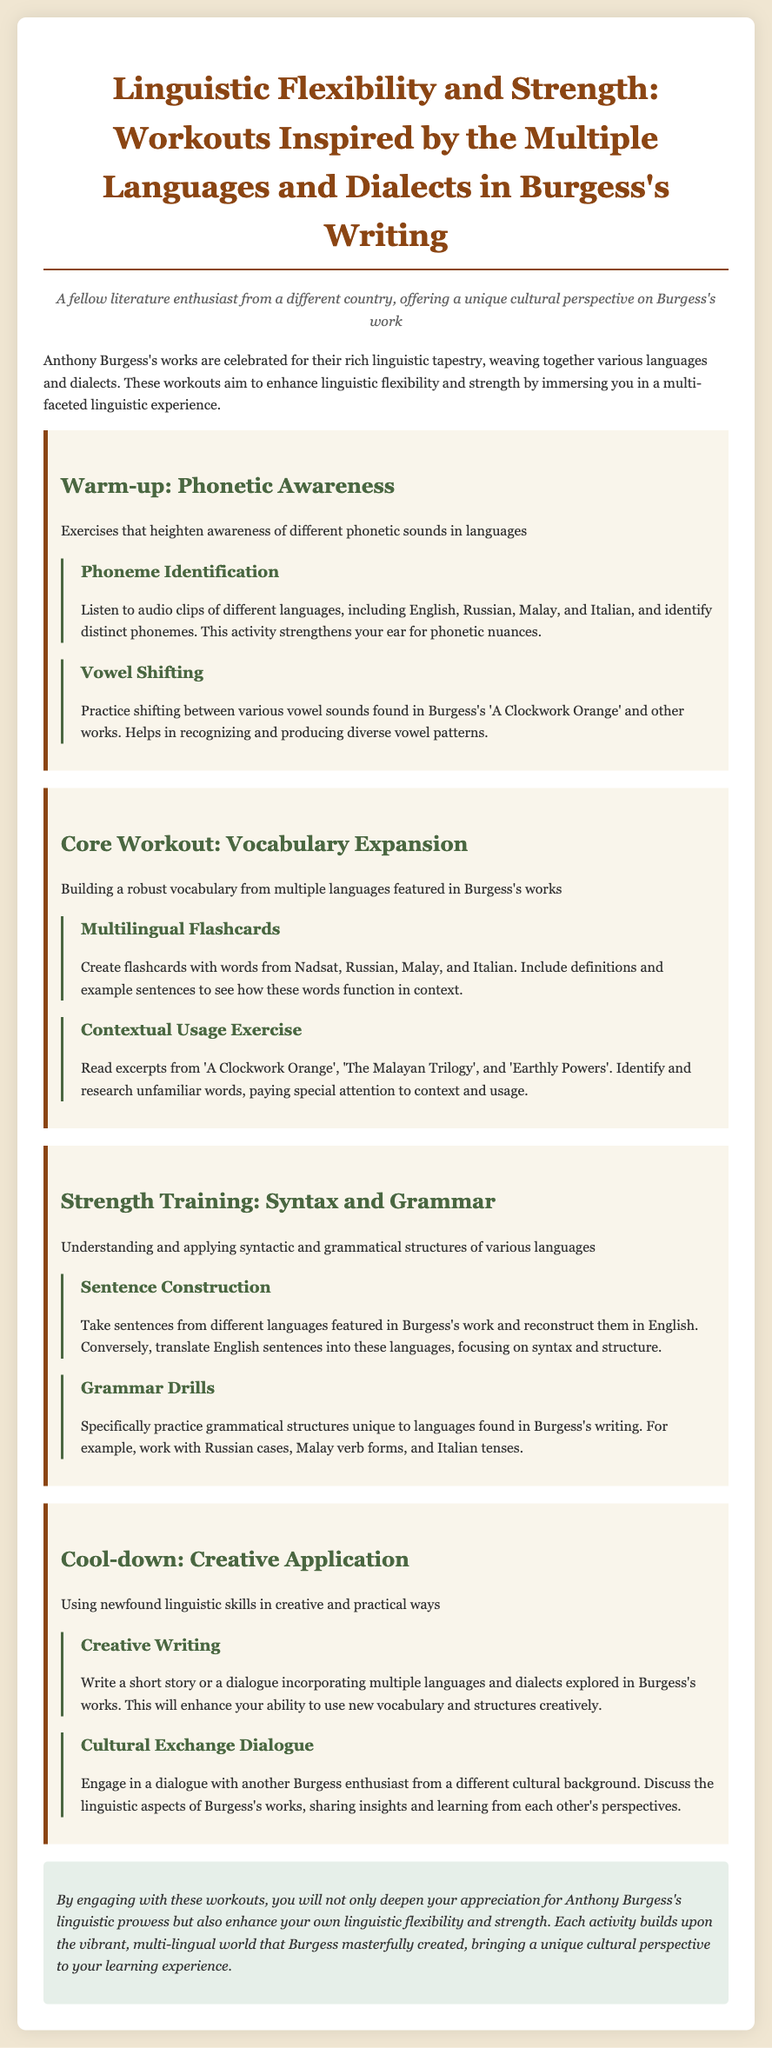What is the title of the document? The title of the document is clearly stated at the top.
Answer: Linguistic Flexibility and Strength: Workouts Inspired by the Multiple Languages and Dialects in Burgess's Writing Who is the target persona described in the document? The document opens with a persona description, identifying the target audience for clarity.
Answer: A fellow literature enthusiast from a different country, offering a unique cultural perspective on Burgess's work What is the first activity listed under the Warm-up section? The first activity is mentioned directly under the Warm-up section heading.
Answer: Phoneme Identification Which work of Burgess is referenced in the Core Workout section? The works mentioned in the Core Workout section are specifically named.
Answer: A Clockwork Orange What type of exercise is found in the Strength Training section? The types of exercises are outlined in the specific sections of the document.
Answer: Syntax and Grammar What is the focus of the Creative Writing activity? The purpose of the Creative Writing activity is explained in the document.
Answer: Incorporating multiple languages and dialects explored in Burgess's works How many activities are listed in the Cool-down section? The number of activities can be determined by counting them in the Cool-down section.
Answer: 2 What is the concluding point of the document? The conclusion summarizes the overall purpose and benefit of the workouts discussed.
Answer: Enhance your own linguistic flexibility and strength 